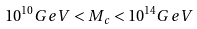<formula> <loc_0><loc_0><loc_500><loc_500>1 0 ^ { 1 0 } G e V < M _ { c } < 1 0 ^ { 1 4 } G e V</formula> 